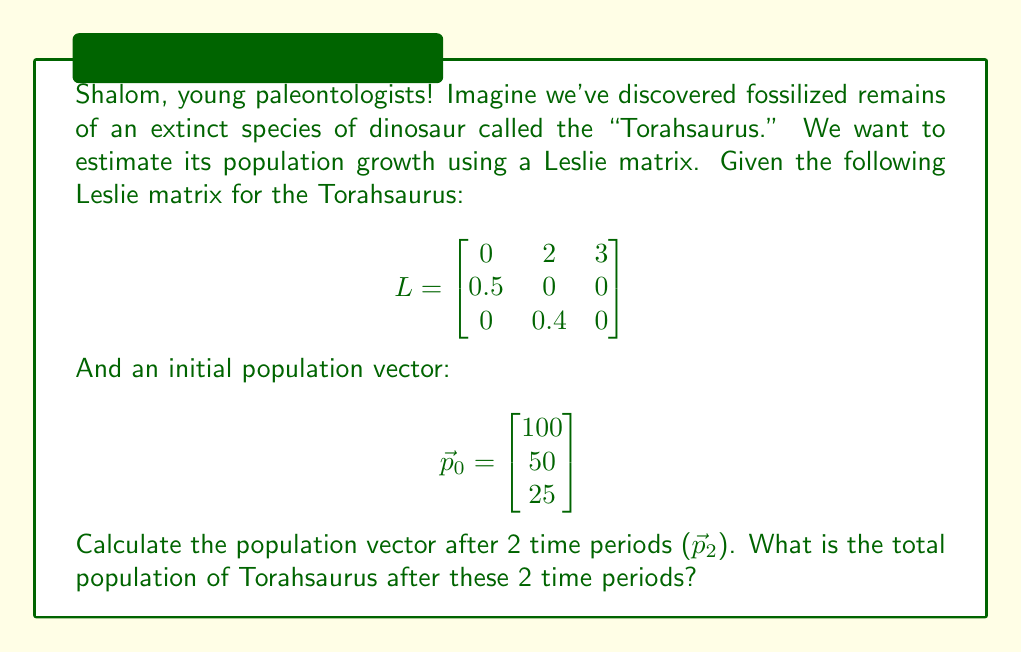Could you help me with this problem? Let's approach this step-by-step, like we're uncovering layers of sediment in a dig:

1) To find the population vector after 2 time periods, we need to multiply the Leslie matrix by the initial population vector twice:

   $$\vec{p}_2 = L^2 \vec{p}_0$$

2) First, let's calculate $$L^2$$:

   $$L^2 = L \times L = \begin{bmatrix}
   0 & 2 & 3 \\
   0.5 & 0 & 0 \\
   0 & 0.4 & 0
   \end{bmatrix} \times \begin{bmatrix}
   0 & 2 & 3 \\
   0.5 & 0 & 0 \\
   0 & 0.4 & 0
   \end{bmatrix}$$

3) Multiplying these matrices:

   $$L^2 = \begin{bmatrix}
   1 & 0.8 & 0 \\
   0 & 1 & 1.5 \\
   0.2 & 0 & 0
   \end{bmatrix}$$

4) Now, let's multiply $$L^2$$ by $$\vec{p}_0$$:

   $$\vec{p}_2 = \begin{bmatrix}
   1 & 0.8 & 0 \\
   0 & 1 & 1.5 \\
   0.2 & 0 & 0
   \end{bmatrix} \times \begin{bmatrix}
   100 \\
   50 \\
   25
   \end{bmatrix}$$

5) Calculating this multiplication:

   $$\vec{p}_2 = \begin{bmatrix}
   (1 \times 100) + (0.8 \times 50) + (0 \times 25) \\
   (0 \times 100) + (1 \times 50) + (1.5 \times 25) \\
   (0.2 \times 100) + (0 \times 50) + (0 \times 25)
   \end{bmatrix} = \begin{bmatrix}
   140 \\
   87.5 \\
   20
   \end{bmatrix}$$

6) To find the total population, we sum the components of $$\vec{p}_2$$:

   Total population = 140 + 87.5 + 20 = 247.5

Therefore, after 2 time periods, there would be 247.5 Torahsaurus (rounded to 248 since we can't have fractional dinosaurs).
Answer: 248 Torahsaurus 